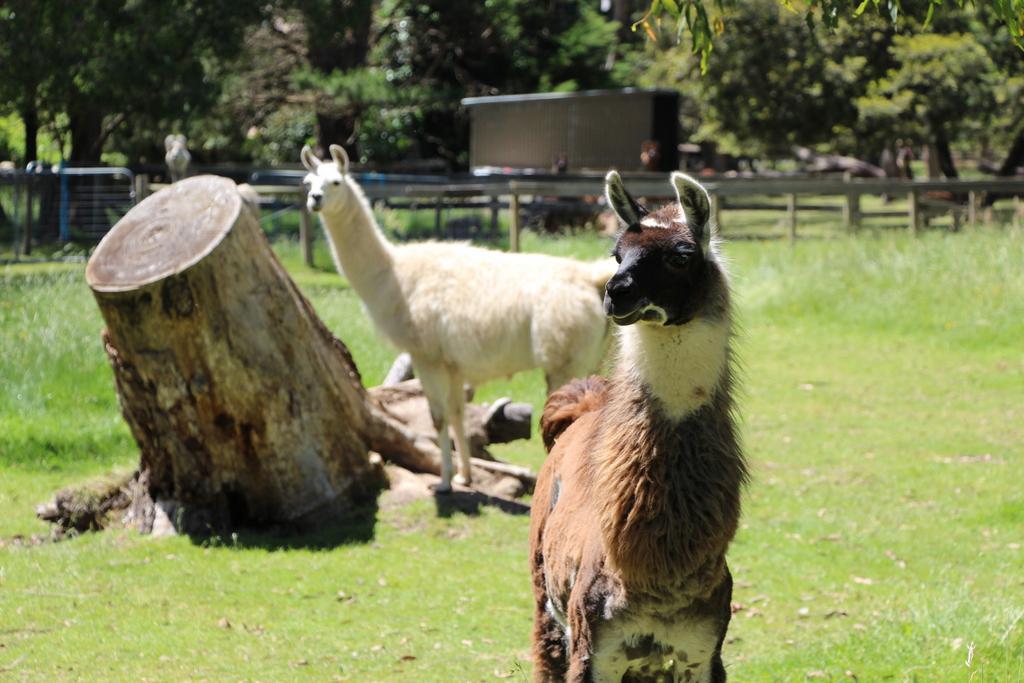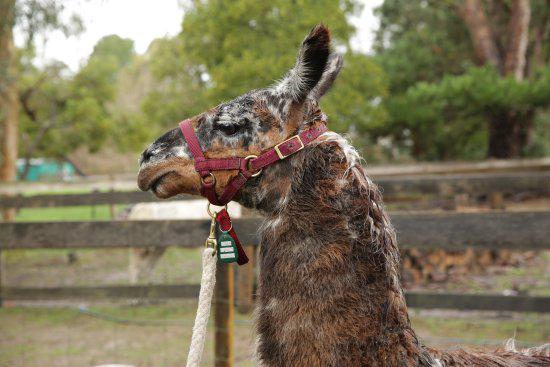The first image is the image on the left, the second image is the image on the right. Given the left and right images, does the statement "There is at least one human in the pair of images." hold true? Answer yes or no. No. The first image is the image on the left, the second image is the image on the right. Considering the images on both sides, is "A white rope is extending from the red harness on a right-facing llama with a mottled brown coat in one image." valid? Answer yes or no. No. 